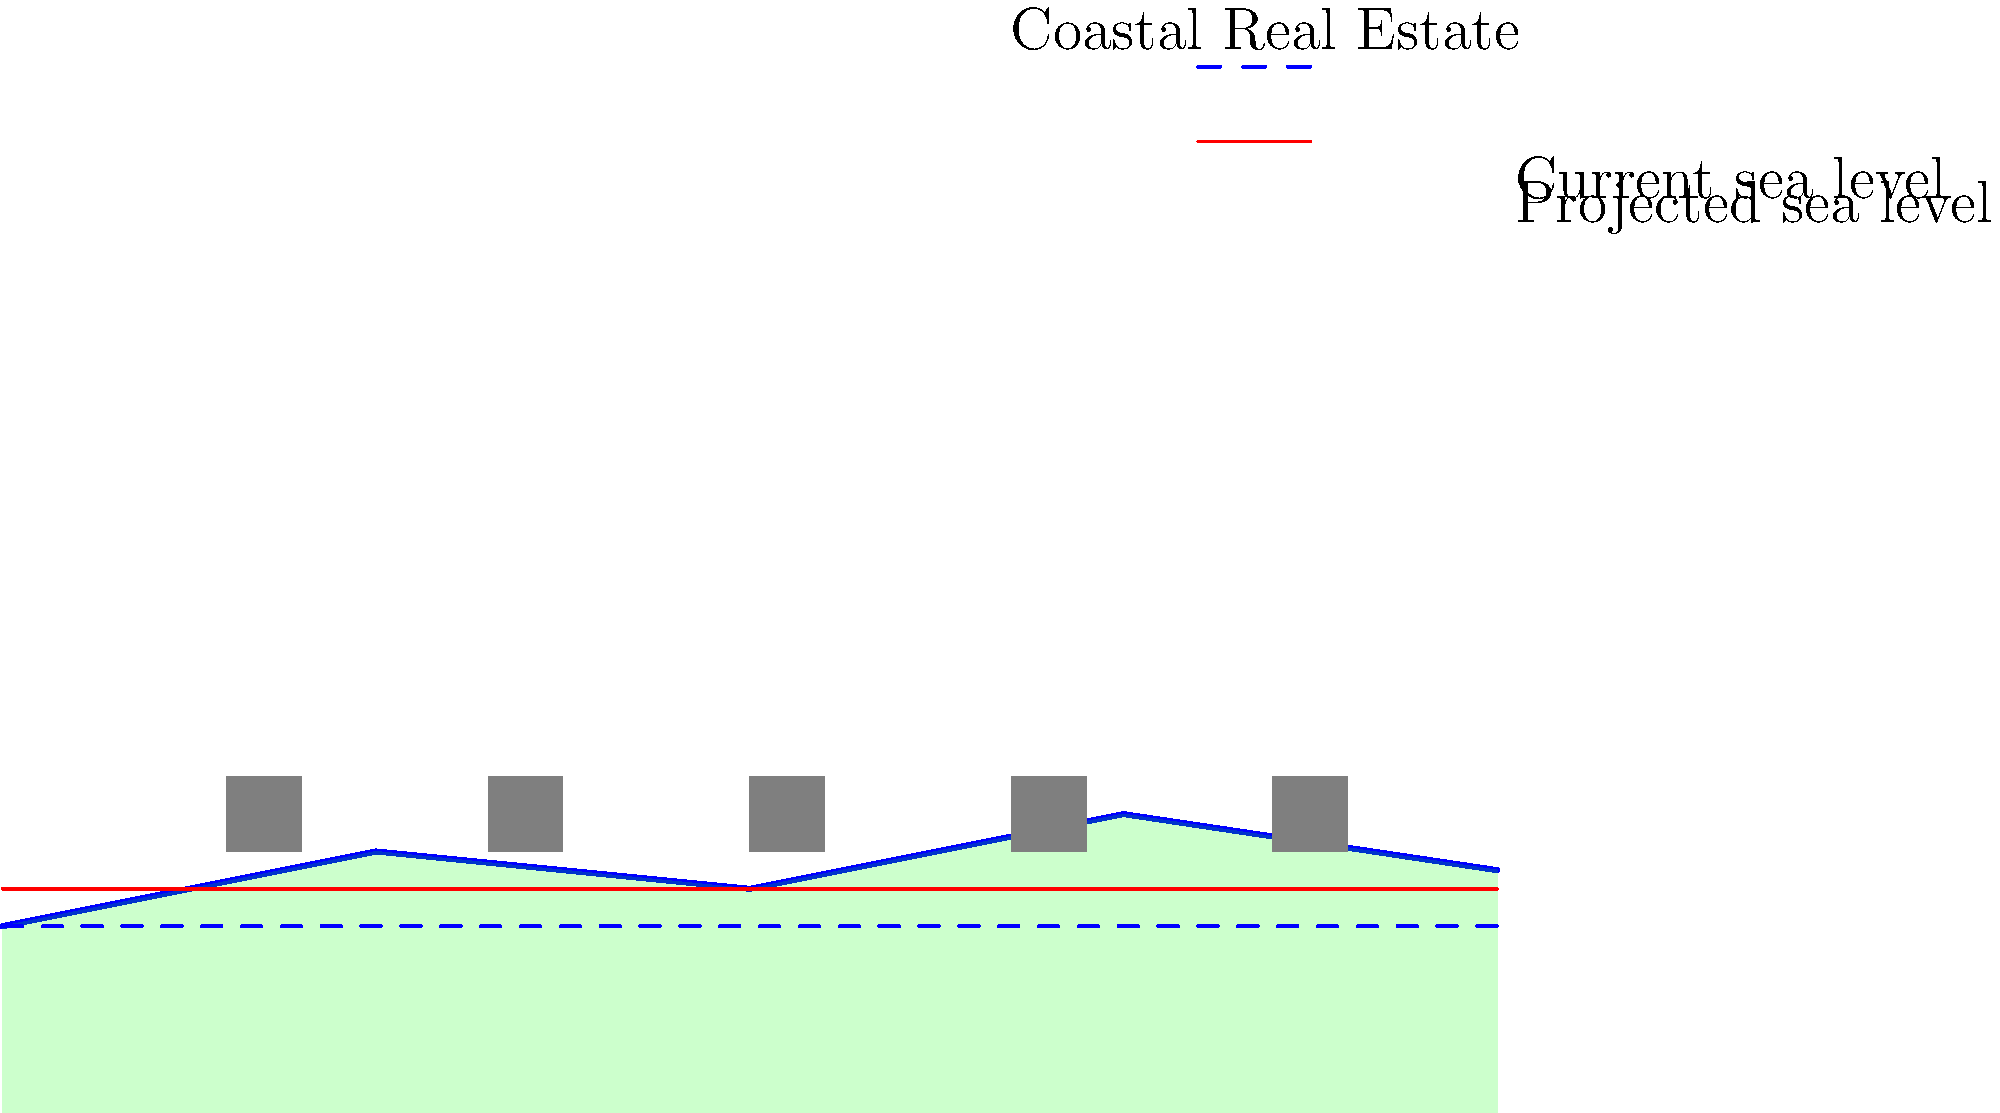Based on the map overlay showing current and projected sea levels along a coastal region with real estate investments, what percentage of the depicted buildings are at risk of being affected by sea level rise? To determine the percentage of buildings at risk from sea level rise, we need to follow these steps:

1. Count the total number of buildings shown on the map:
   There are 5 buildings depicted.

2. Identify the buildings below the projected sea level (red line):
   The first two buildings from the left are clearly below the red line representing the projected sea level.

3. Calculate the percentage:
   Number of buildings at risk = 2
   Total number of buildings = 5
   
   Percentage = (Number of buildings at risk / Total number of buildings) * 100
               = (2 / 5) * 100
               = 0.4 * 100
               = 40%

Therefore, 40% of the depicted buildings are at risk of being affected by sea level rise according to the projection shown in the map overlay.
Answer: 40% 